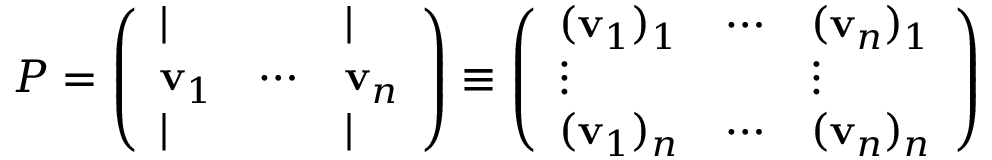Convert formula to latex. <formula><loc_0><loc_0><loc_500><loc_500>P = { \left ( \begin{array} { l l l } { | } & { | } \\ { v _ { 1 } } & { \cdots } & { v _ { n } } \\ { | } & { | } \end{array} \right ) } \equiv \left ( \begin{array} { l l l } { ( v _ { 1 } ) _ { 1 } } & { \cdots } & { ( v _ { n } ) _ { 1 } } \\ { \vdots } & { \vdots } \\ { ( v _ { 1 } ) _ { n } } & { \cdots } & { ( v _ { n } ) _ { n } } \end{array} \right )</formula> 